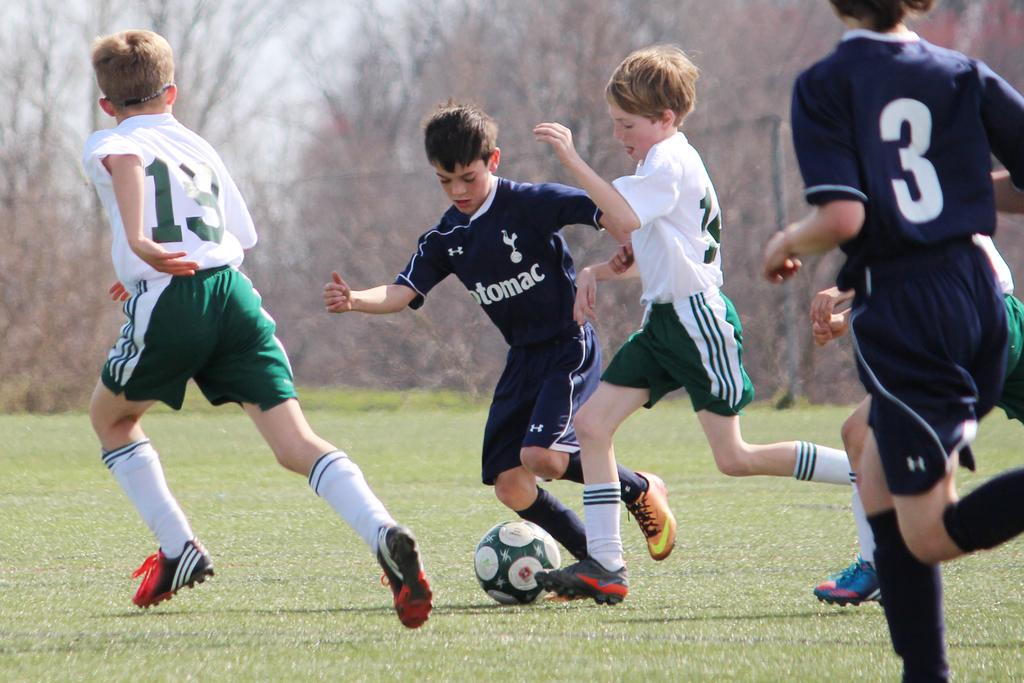What is happening in the image involving a group of kids? The kids are playing football in the image. What is the setting for the football game? The football game is taking place on a green ground. What can be seen in the background of the image? There are trees in the background of the image. What significant discovery was made by the kids during the game, as seen in the image? There is no mention of a discovery in the image; the kids are simply playing football on a green ground with trees in the background. 